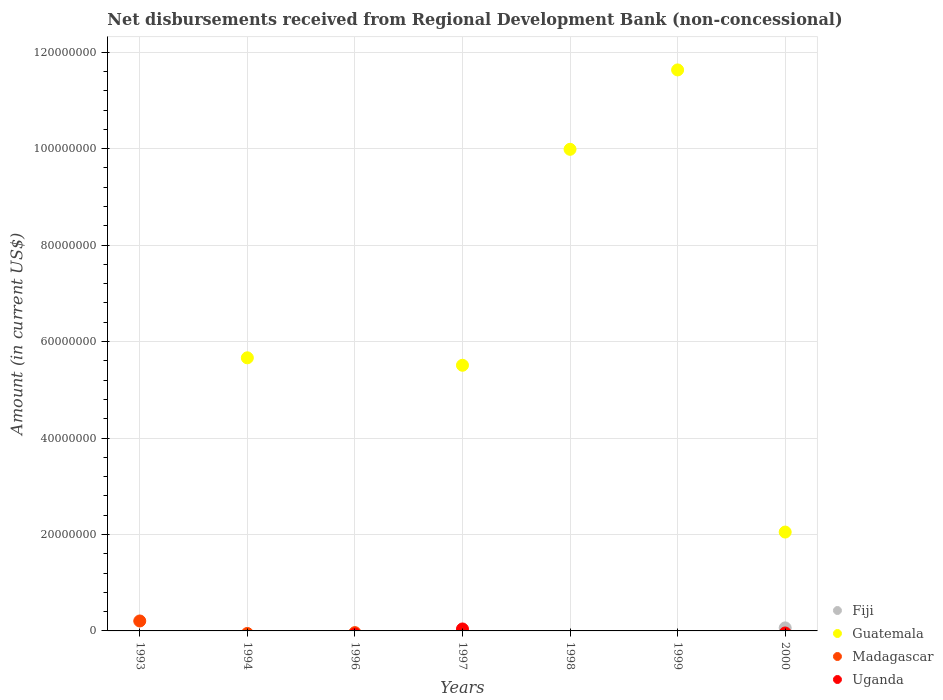Is the number of dotlines equal to the number of legend labels?
Your response must be concise. No. What is the amount of disbursements received from Regional Development Bank in Guatemala in 1999?
Give a very brief answer. 1.16e+08. Across all years, what is the maximum amount of disbursements received from Regional Development Bank in Uganda?
Offer a very short reply. 4.06e+05. In which year was the amount of disbursements received from Regional Development Bank in Madagascar maximum?
Offer a very short reply. 1993. What is the total amount of disbursements received from Regional Development Bank in Guatemala in the graph?
Give a very brief answer. 3.48e+08. What is the difference between the amount of disbursements received from Regional Development Bank in Guatemala in 1994 and that in 1997?
Provide a short and direct response. 1.54e+06. What is the difference between the amount of disbursements received from Regional Development Bank in Guatemala in 2000 and the amount of disbursements received from Regional Development Bank in Uganda in 1996?
Your response must be concise. 2.05e+07. What is the average amount of disbursements received from Regional Development Bank in Madagascar per year?
Offer a terse response. 2.94e+05. In how many years, is the amount of disbursements received from Regional Development Bank in Uganda greater than 36000000 US$?
Your response must be concise. 0. What is the difference between the highest and the second highest amount of disbursements received from Regional Development Bank in Guatemala?
Ensure brevity in your answer.  1.65e+07. What is the difference between the highest and the lowest amount of disbursements received from Regional Development Bank in Fiji?
Your answer should be very brief. 6.27e+05. Is it the case that in every year, the sum of the amount of disbursements received from Regional Development Bank in Madagascar and amount of disbursements received from Regional Development Bank in Fiji  is greater than the sum of amount of disbursements received from Regional Development Bank in Uganda and amount of disbursements received from Regional Development Bank in Guatemala?
Make the answer very short. No. Is it the case that in every year, the sum of the amount of disbursements received from Regional Development Bank in Madagascar and amount of disbursements received from Regional Development Bank in Fiji  is greater than the amount of disbursements received from Regional Development Bank in Uganda?
Ensure brevity in your answer.  No. Does the amount of disbursements received from Regional Development Bank in Fiji monotonically increase over the years?
Provide a short and direct response. No. How many dotlines are there?
Your response must be concise. 4. Are the values on the major ticks of Y-axis written in scientific E-notation?
Your response must be concise. No. Does the graph contain any zero values?
Offer a terse response. Yes. Does the graph contain grids?
Your answer should be compact. Yes. Where does the legend appear in the graph?
Your answer should be very brief. Bottom right. How are the legend labels stacked?
Your answer should be compact. Vertical. What is the title of the graph?
Offer a very short reply. Net disbursements received from Regional Development Bank (non-concessional). What is the label or title of the X-axis?
Offer a terse response. Years. What is the Amount (in current US$) of Fiji in 1993?
Your response must be concise. 0. What is the Amount (in current US$) of Madagascar in 1993?
Make the answer very short. 2.06e+06. What is the Amount (in current US$) of Fiji in 1994?
Provide a short and direct response. 0. What is the Amount (in current US$) in Guatemala in 1994?
Provide a short and direct response. 5.66e+07. What is the Amount (in current US$) in Fiji in 1996?
Your response must be concise. 0. What is the Amount (in current US$) in Madagascar in 1996?
Provide a short and direct response. 0. What is the Amount (in current US$) of Uganda in 1996?
Your response must be concise. 0. What is the Amount (in current US$) of Guatemala in 1997?
Your response must be concise. 5.51e+07. What is the Amount (in current US$) of Madagascar in 1997?
Your answer should be very brief. 0. What is the Amount (in current US$) in Uganda in 1997?
Ensure brevity in your answer.  4.06e+05. What is the Amount (in current US$) of Guatemala in 1998?
Provide a succinct answer. 9.99e+07. What is the Amount (in current US$) in Fiji in 1999?
Your answer should be very brief. 0. What is the Amount (in current US$) of Guatemala in 1999?
Give a very brief answer. 1.16e+08. What is the Amount (in current US$) of Fiji in 2000?
Keep it short and to the point. 6.27e+05. What is the Amount (in current US$) of Guatemala in 2000?
Keep it short and to the point. 2.05e+07. What is the Amount (in current US$) of Uganda in 2000?
Give a very brief answer. 0. Across all years, what is the maximum Amount (in current US$) in Fiji?
Provide a short and direct response. 6.27e+05. Across all years, what is the maximum Amount (in current US$) in Guatemala?
Offer a terse response. 1.16e+08. Across all years, what is the maximum Amount (in current US$) of Madagascar?
Give a very brief answer. 2.06e+06. Across all years, what is the maximum Amount (in current US$) of Uganda?
Give a very brief answer. 4.06e+05. Across all years, what is the minimum Amount (in current US$) in Guatemala?
Offer a very short reply. 0. What is the total Amount (in current US$) in Fiji in the graph?
Offer a terse response. 6.27e+05. What is the total Amount (in current US$) of Guatemala in the graph?
Your answer should be very brief. 3.48e+08. What is the total Amount (in current US$) in Madagascar in the graph?
Your response must be concise. 2.06e+06. What is the total Amount (in current US$) of Uganda in the graph?
Your answer should be very brief. 4.06e+05. What is the difference between the Amount (in current US$) in Guatemala in 1994 and that in 1997?
Provide a short and direct response. 1.54e+06. What is the difference between the Amount (in current US$) in Guatemala in 1994 and that in 1998?
Your answer should be very brief. -4.32e+07. What is the difference between the Amount (in current US$) in Guatemala in 1994 and that in 1999?
Your answer should be very brief. -5.97e+07. What is the difference between the Amount (in current US$) in Guatemala in 1994 and that in 2000?
Your response must be concise. 3.61e+07. What is the difference between the Amount (in current US$) in Guatemala in 1997 and that in 1998?
Provide a short and direct response. -4.48e+07. What is the difference between the Amount (in current US$) in Guatemala in 1997 and that in 1999?
Keep it short and to the point. -6.12e+07. What is the difference between the Amount (in current US$) in Guatemala in 1997 and that in 2000?
Provide a short and direct response. 3.46e+07. What is the difference between the Amount (in current US$) in Guatemala in 1998 and that in 1999?
Your answer should be compact. -1.65e+07. What is the difference between the Amount (in current US$) in Guatemala in 1998 and that in 2000?
Keep it short and to the point. 7.94e+07. What is the difference between the Amount (in current US$) in Guatemala in 1999 and that in 2000?
Your response must be concise. 9.58e+07. What is the difference between the Amount (in current US$) in Madagascar in 1993 and the Amount (in current US$) in Uganda in 1997?
Ensure brevity in your answer.  1.66e+06. What is the difference between the Amount (in current US$) in Guatemala in 1994 and the Amount (in current US$) in Uganda in 1997?
Offer a terse response. 5.62e+07. What is the average Amount (in current US$) in Fiji per year?
Keep it short and to the point. 8.96e+04. What is the average Amount (in current US$) in Guatemala per year?
Your answer should be compact. 4.98e+07. What is the average Amount (in current US$) of Madagascar per year?
Ensure brevity in your answer.  2.94e+05. What is the average Amount (in current US$) of Uganda per year?
Keep it short and to the point. 5.80e+04. In the year 1997, what is the difference between the Amount (in current US$) in Guatemala and Amount (in current US$) in Uganda?
Offer a terse response. 5.47e+07. In the year 2000, what is the difference between the Amount (in current US$) in Fiji and Amount (in current US$) in Guatemala?
Provide a succinct answer. -1.99e+07. What is the ratio of the Amount (in current US$) in Guatemala in 1994 to that in 1997?
Ensure brevity in your answer.  1.03. What is the ratio of the Amount (in current US$) of Guatemala in 1994 to that in 1998?
Offer a very short reply. 0.57. What is the ratio of the Amount (in current US$) of Guatemala in 1994 to that in 1999?
Give a very brief answer. 0.49. What is the ratio of the Amount (in current US$) of Guatemala in 1994 to that in 2000?
Your answer should be very brief. 2.76. What is the ratio of the Amount (in current US$) of Guatemala in 1997 to that in 1998?
Offer a very short reply. 0.55. What is the ratio of the Amount (in current US$) of Guatemala in 1997 to that in 1999?
Make the answer very short. 0.47. What is the ratio of the Amount (in current US$) of Guatemala in 1997 to that in 2000?
Offer a terse response. 2.69. What is the ratio of the Amount (in current US$) in Guatemala in 1998 to that in 1999?
Ensure brevity in your answer.  0.86. What is the ratio of the Amount (in current US$) of Guatemala in 1998 to that in 2000?
Offer a terse response. 4.87. What is the ratio of the Amount (in current US$) of Guatemala in 1999 to that in 2000?
Make the answer very short. 5.67. What is the difference between the highest and the second highest Amount (in current US$) in Guatemala?
Provide a short and direct response. 1.65e+07. What is the difference between the highest and the lowest Amount (in current US$) in Fiji?
Offer a very short reply. 6.27e+05. What is the difference between the highest and the lowest Amount (in current US$) of Guatemala?
Your answer should be very brief. 1.16e+08. What is the difference between the highest and the lowest Amount (in current US$) in Madagascar?
Ensure brevity in your answer.  2.06e+06. What is the difference between the highest and the lowest Amount (in current US$) of Uganda?
Ensure brevity in your answer.  4.06e+05. 